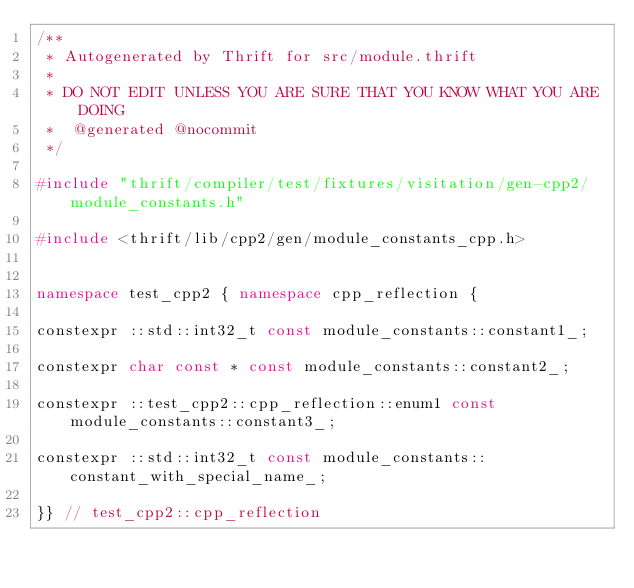Convert code to text. <code><loc_0><loc_0><loc_500><loc_500><_C++_>/**
 * Autogenerated by Thrift for src/module.thrift
 *
 * DO NOT EDIT UNLESS YOU ARE SURE THAT YOU KNOW WHAT YOU ARE DOING
 *  @generated @nocommit
 */

#include "thrift/compiler/test/fixtures/visitation/gen-cpp2/module_constants.h"

#include <thrift/lib/cpp2/gen/module_constants_cpp.h>


namespace test_cpp2 { namespace cpp_reflection {

constexpr ::std::int32_t const module_constants::constant1_;

constexpr char const * const module_constants::constant2_;

constexpr ::test_cpp2::cpp_reflection::enum1 const module_constants::constant3_;

constexpr ::std::int32_t const module_constants::constant_with_special_name_;

}} // test_cpp2::cpp_reflection
</code> 